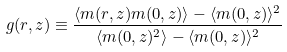<formula> <loc_0><loc_0><loc_500><loc_500>g ( r , z ) \equiv \frac { \langle m ( r , z ) m ( 0 , z ) \rangle - \langle m ( 0 , z ) \rangle ^ { 2 } } { \langle m ( 0 , z ) ^ { 2 } \rangle - \langle m ( 0 , z ) \rangle ^ { 2 } }</formula> 